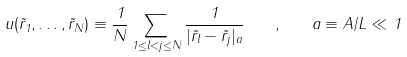Convert formula to latex. <formula><loc_0><loc_0><loc_500><loc_500>u ( { \vec { r } } _ { 1 } , \dots , { \vec { r } } _ { N } ) \equiv \frac { 1 } { N } \sum _ { 1 \leq l < j \leq N } \frac { 1 } { | { \vec { r } } _ { l } - { \vec { r } } _ { j } | _ { a } } \quad , \quad a \equiv A / L \ll 1</formula> 